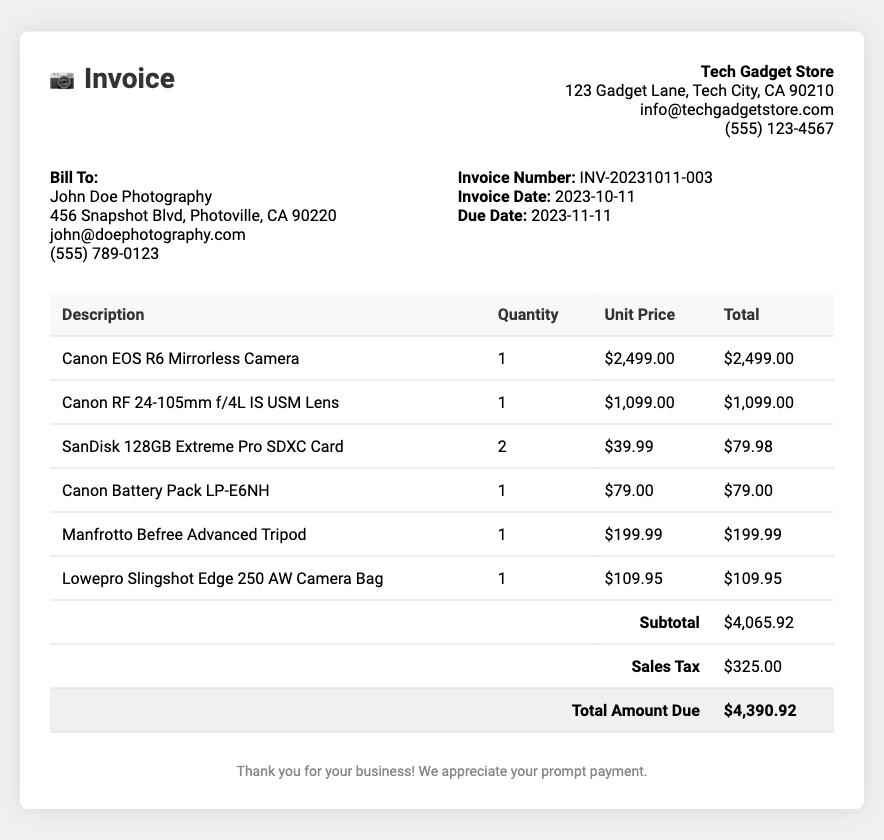What is the invoice number? The invoice number is mentioned under the invoice info section in the document.
Answer: INV-20231011-003 What is the purchase date of the invoice? The purchase date can be found in the invoice details section.
Answer: 2023-10-11 What is the total amount due? The total amount due is listed at the bottom of the invoice table.
Answer: $4,390.92 Which camera model was purchased? The camera model is specified in the description section of the invoice.
Answer: Canon EOS R6 Mirrorless Camera How many SanDisk SD cards were bought? The quantity of SanDisk SD cards purchased is indicated in the invoice.
Answer: 2 What is the subtotal amount before tax? The subtotal amount is stated just above the sales tax entry in the invoice.
Answer: $4,065.92 What is the sales tax amount? The sales tax amount is presented in the invoice under its own entry.
Answer: $325.00 What brand is the tripods? The brand of the tripod is noted in the description column of the invoice.
Answer: Manfrotto What type of lens was included in the purchase? The type of lens included is specified in the invoice item description.
Answer: Canon RF 24-105mm f/4L IS USM Lens 